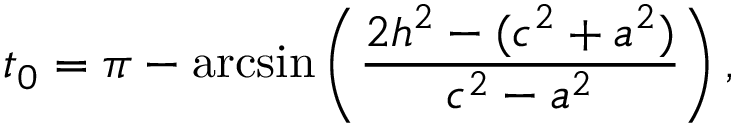<formula> <loc_0><loc_0><loc_500><loc_500>t _ { 0 } = \pi - \arcsin \left ( \frac { 2 h ^ { 2 } - ( c ^ { 2 } + a ^ { 2 } ) } { c ^ { 2 } - a ^ { 2 } } \right ) ,</formula> 